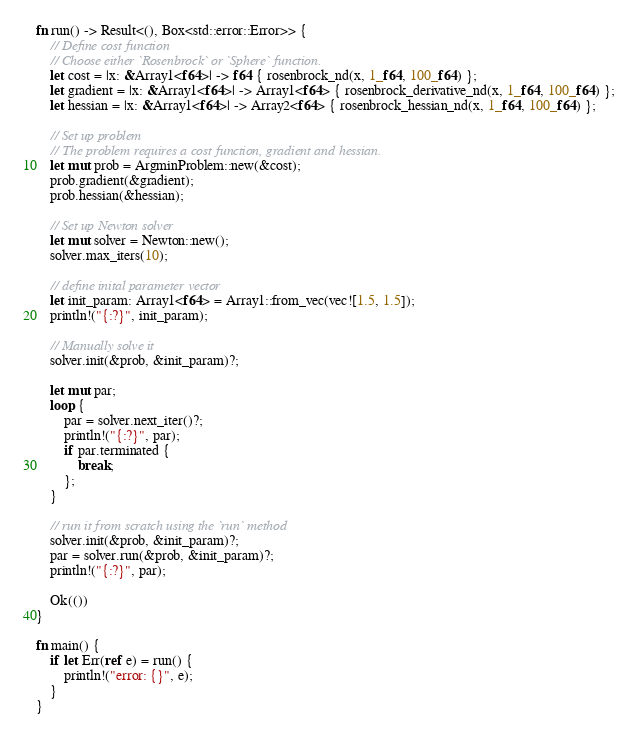Convert code to text. <code><loc_0><loc_0><loc_500><loc_500><_Rust_>fn run() -> Result<(), Box<std::error::Error>> {
    // Define cost function
    // Choose either `Rosenbrock` or `Sphere` function.
    let cost = |x: &Array1<f64>| -> f64 { rosenbrock_nd(x, 1_f64, 100_f64) };
    let gradient = |x: &Array1<f64>| -> Array1<f64> { rosenbrock_derivative_nd(x, 1_f64, 100_f64) };
    let hessian = |x: &Array1<f64>| -> Array2<f64> { rosenbrock_hessian_nd(x, 1_f64, 100_f64) };

    // Set up problem
    // The problem requires a cost function, gradient and hessian.
    let mut prob = ArgminProblem::new(&cost);
    prob.gradient(&gradient);
    prob.hessian(&hessian);

    // Set up Newton solver
    let mut solver = Newton::new();
    solver.max_iters(10);

    // define inital parameter vector
    let init_param: Array1<f64> = Array1::from_vec(vec![1.5, 1.5]);
    println!("{:?}", init_param);

    // Manually solve it
    solver.init(&prob, &init_param)?;

    let mut par;
    loop {
        par = solver.next_iter()?;
        println!("{:?}", par);
        if par.terminated {
            break;
        };
    }

    // run it from scratch using the `run` method
    solver.init(&prob, &init_param)?;
    par = solver.run(&prob, &init_param)?;
    println!("{:?}", par);

    Ok(())
}

fn main() {
    if let Err(ref e) = run() {
        println!("error: {}", e);
    }
}
</code> 